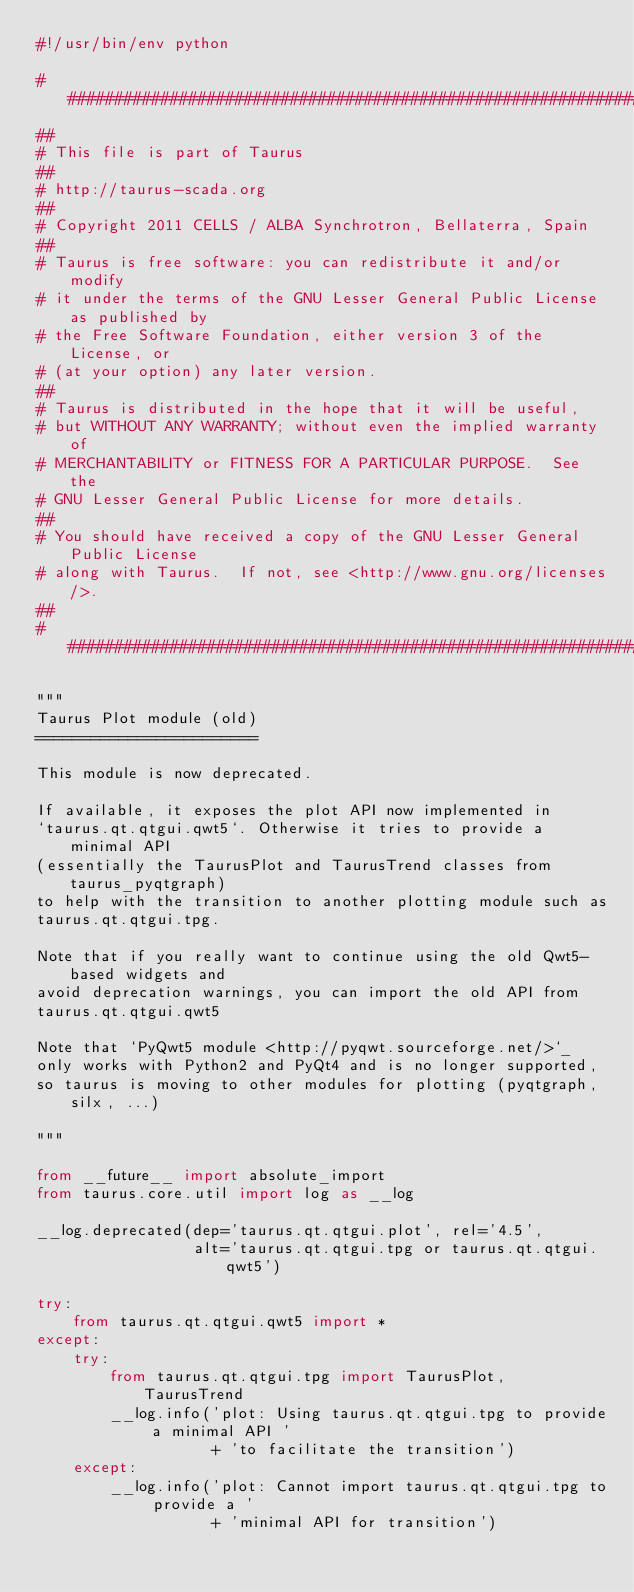Convert code to text. <code><loc_0><loc_0><loc_500><loc_500><_Python_>#!/usr/bin/env python

#############################################################################
##
# This file is part of Taurus
##
# http://taurus-scada.org
##
# Copyright 2011 CELLS / ALBA Synchrotron, Bellaterra, Spain
##
# Taurus is free software: you can redistribute it and/or modify
# it under the terms of the GNU Lesser General Public License as published by
# the Free Software Foundation, either version 3 of the License, or
# (at your option) any later version.
##
# Taurus is distributed in the hope that it will be useful,
# but WITHOUT ANY WARRANTY; without even the implied warranty of
# MERCHANTABILITY or FITNESS FOR A PARTICULAR PURPOSE.  See the
# GNU Lesser General Public License for more details.
##
# You should have received a copy of the GNU Lesser General Public License
# along with Taurus.  If not, see <http://www.gnu.org/licenses/>.
##
#############################################################################

"""
Taurus Plot module (old)
========================

This module is now deprecated.

If available, it exposes the plot API now implemented in
`taurus.qt.qtgui.qwt5`. Otherwise it tries to provide a minimal API
(essentially the TaurusPlot and TaurusTrend classes from taurus_pyqtgraph)
to help with the transition to another plotting module such as
taurus.qt.qtgui.tpg.

Note that if you really want to continue using the old Qwt5-based widgets and
avoid deprecation warnings, you can import the old API from
taurus.qt.qtgui.qwt5

Note that `PyQwt5 module <http://pyqwt.sourceforge.net/>`_
only works with Python2 and PyQt4 and is no longer supported,
so taurus is moving to other modules for plotting (pyqtgraph, silx, ...)

"""

from __future__ import absolute_import
from taurus.core.util import log as __log

__log.deprecated(dep='taurus.qt.qtgui.plot', rel='4.5',
                 alt='taurus.qt.qtgui.tpg or taurus.qt.qtgui.qwt5')

try:
    from taurus.qt.qtgui.qwt5 import *
except:
    try:
        from taurus.qt.qtgui.tpg import TaurusPlot, TaurusTrend
        __log.info('plot: Using taurus.qt.qtgui.tpg to provide a minimal API '
                   + 'to facilitate the transition')
    except:
        __log.info('plot: Cannot import taurus.qt.qtgui.tpg to provide a '
                   + 'minimal API for transition')



</code> 